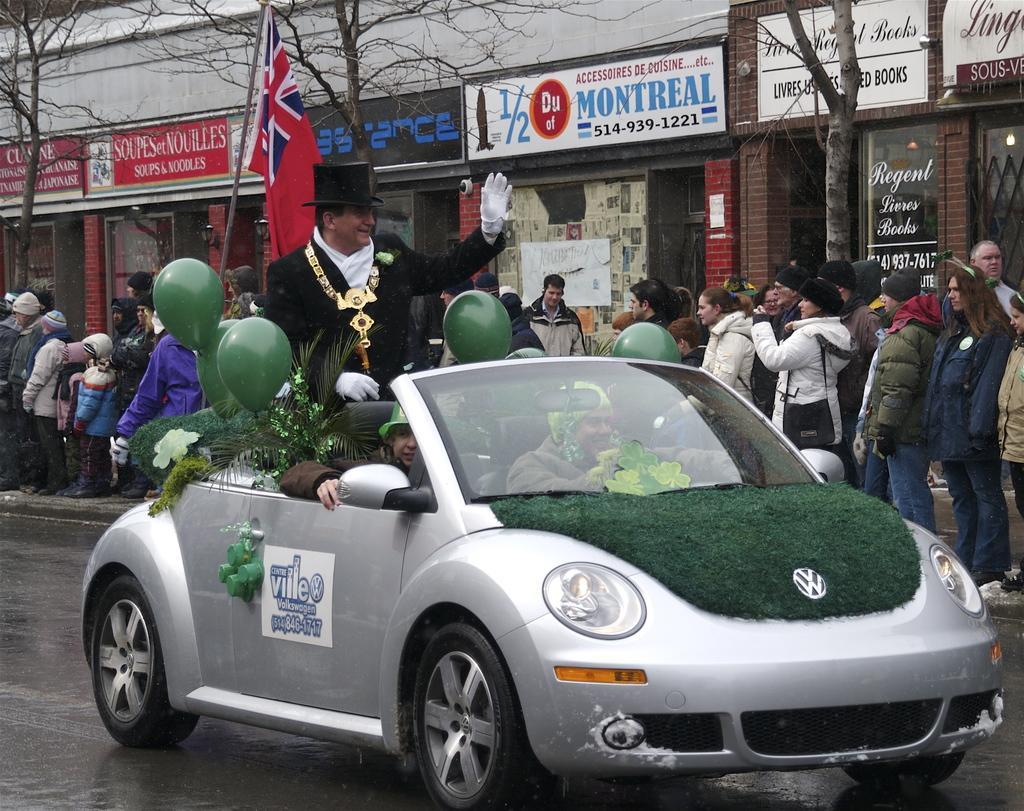Can you describe this image briefly? This image consists of a car and so many people are standing in the middle. Behind them there are so many stores and trees. In the car there are three people. One man is wearing hat and holding balloons. That car has headlight tires and Mirrors. 